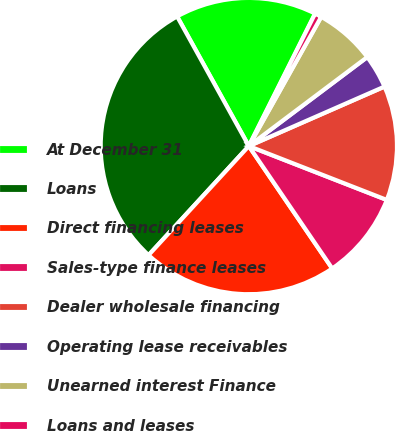Convert chart. <chart><loc_0><loc_0><loc_500><loc_500><pie_chart><fcel>At December 31<fcel>Loans<fcel>Direct financing leases<fcel>Sales-type finance leases<fcel>Dealer wholesale financing<fcel>Operating lease receivables<fcel>Unearned interest Finance<fcel>Loans and leases<nl><fcel>15.43%<fcel>30.13%<fcel>21.35%<fcel>9.56%<fcel>12.5%<fcel>3.68%<fcel>6.62%<fcel>0.74%<nl></chart> 